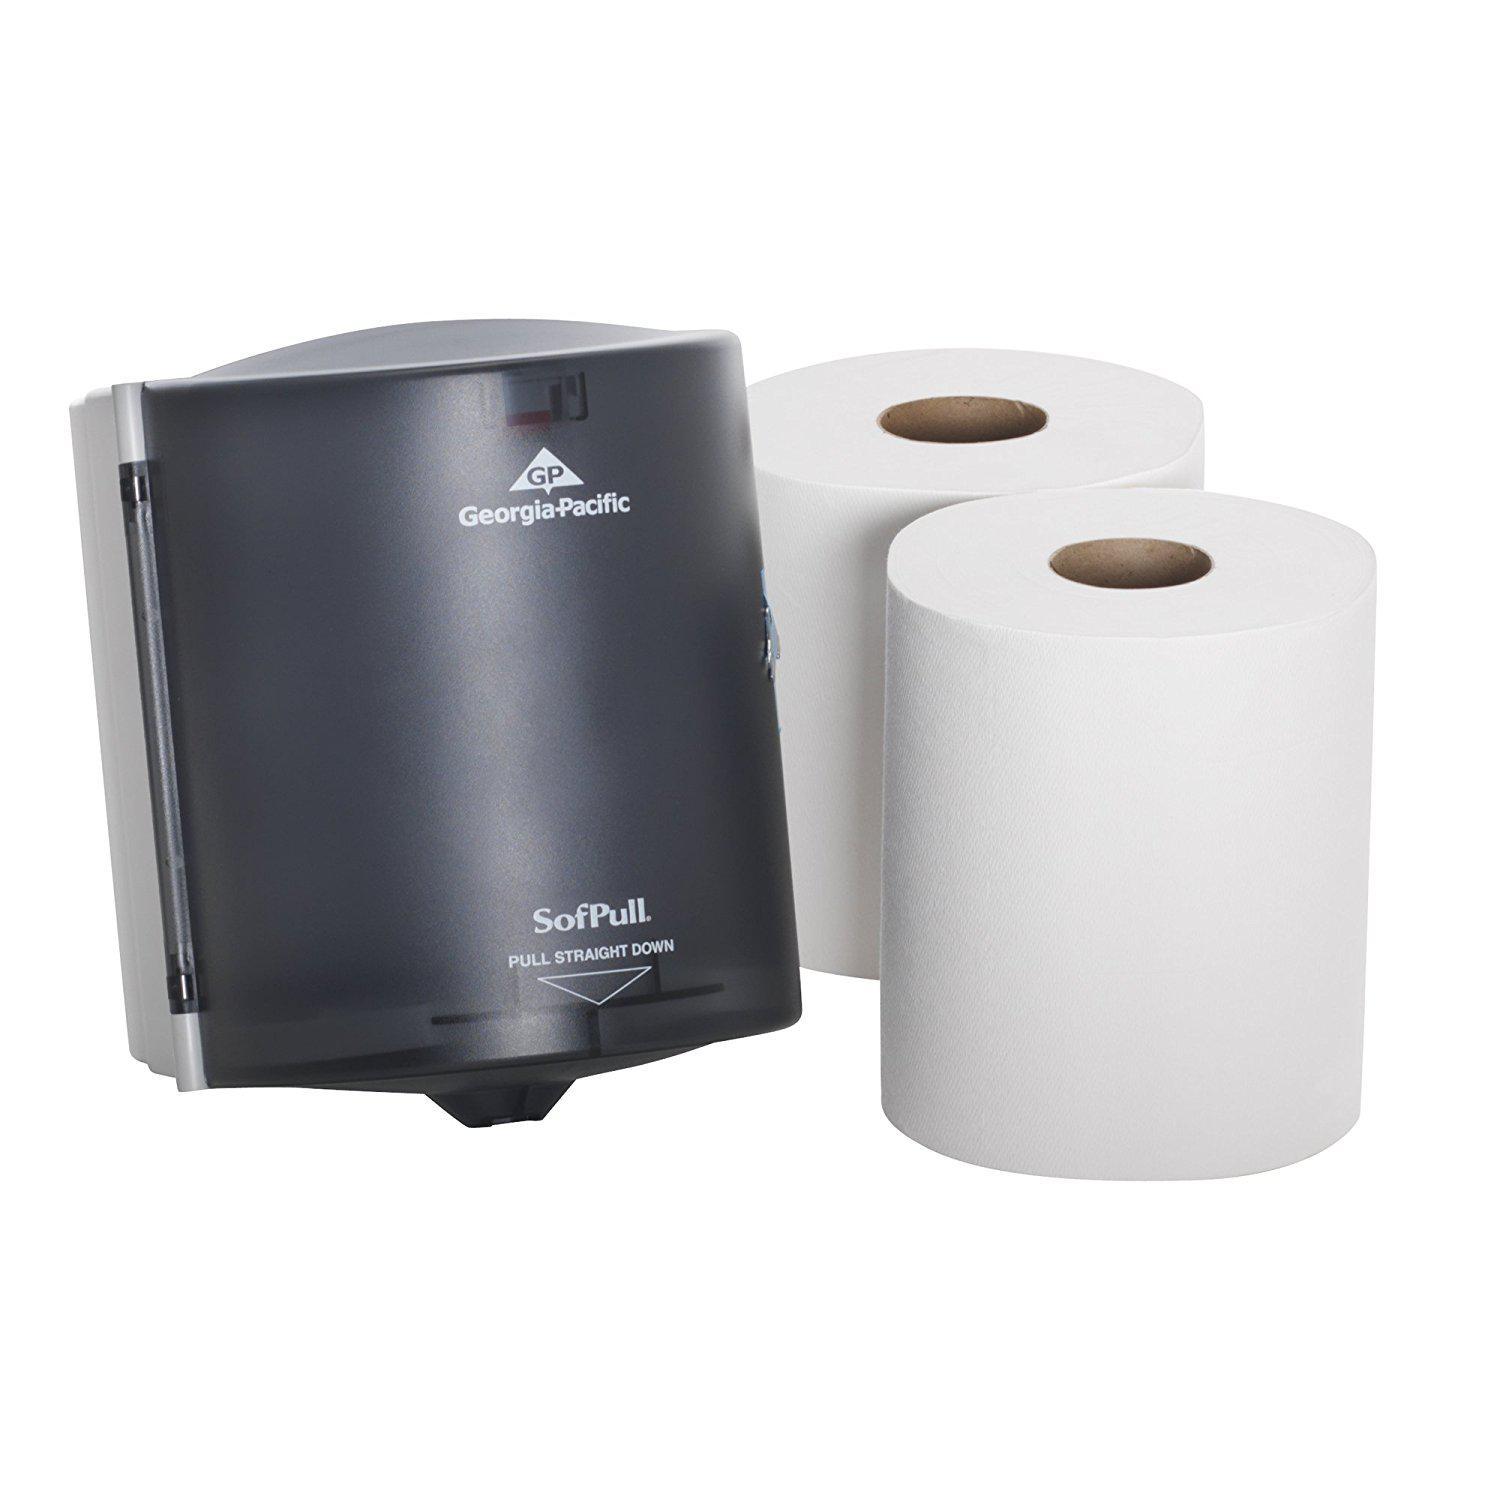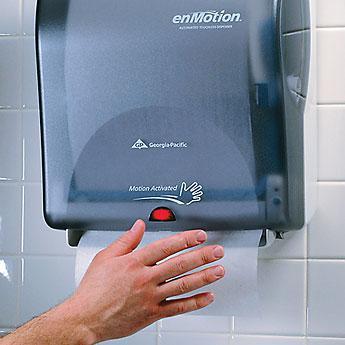The first image is the image on the left, the second image is the image on the right. Evaluate the accuracy of this statement regarding the images: "In one of the image there are two paper rolls next to a paper towel dispenser.". Is it true? Answer yes or no. Yes. The first image is the image on the left, the second image is the image on the right. Considering the images on both sides, is "The image on the right shows a person reaching for a disposable paper towel." valid? Answer yes or no. Yes. 